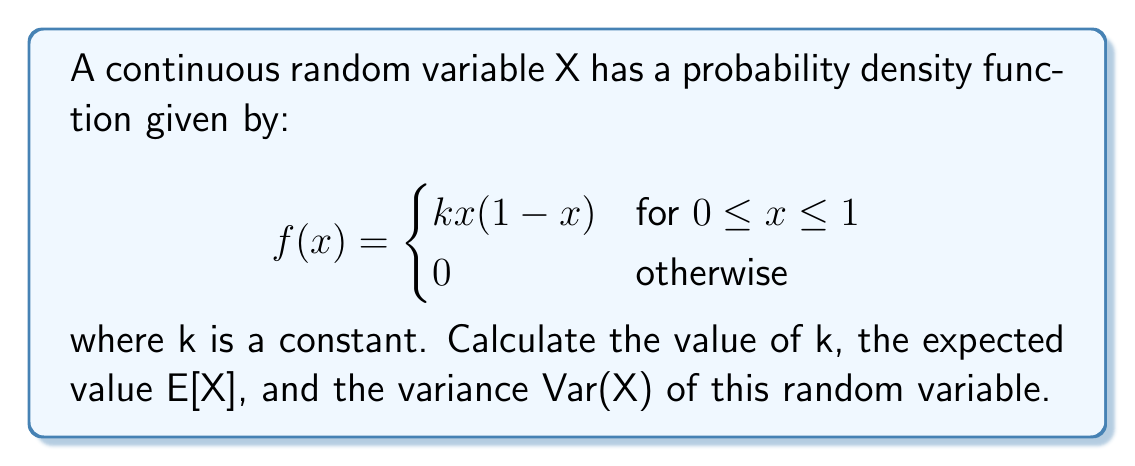What is the answer to this math problem? 1. First, we need to find the value of k. Since this is a probability density function, the total area under the curve must equal 1:

   $$\int_{0}^{1} kx(1-x) dx = 1$$

   Solving this integral:
   $$k \int_{0}^{1} (x - x^2) dx = 1$$
   $$k [\frac{x^2}{2} - \frac{x^3}{3}]_{0}^{1} = 1$$
   $$k (\frac{1}{2} - \frac{1}{3}) = 1$$
   $$k = 6$$

2. Now we can calculate the expected value E[X]:

   $$E[X] = \int_{0}^{1} x \cdot 6x(1-x) dx$$
   $$= 6 \int_{0}^{1} (x^2 - x^3) dx$$
   $$= 6 [\frac{x^3}{3} - \frac{x^4}{4}]_{0}^{1}$$
   $$= 6 (\frac{1}{3} - \frac{1}{4}) = 6 \cdot \frac{1}{12} = \frac{1}{2}$$

3. To find the variance, we first need to calculate E[X^2]:

   $$E[X^2] = \int_{0}^{1} x^2 \cdot 6x(1-x) dx$$
   $$= 6 \int_{0}^{1} (x^3 - x^4) dx$$
   $$= 6 [\frac{x^4}{4} - \frac{x^5}{5}]_{0}^{1}$$
   $$= 6 (\frac{1}{4} - \frac{1}{5}) = 6 \cdot \frac{1}{20} = \frac{3}{10}$$

4. Now we can calculate the variance:

   $$Var(X) = E[X^2] - (E[X])^2$$
   $$= \frac{3}{10} - (\frac{1}{2})^2$$
   $$= \frac{3}{10} - \frac{1}{4} = \frac{1}{20}$$
Answer: $k = 6$, $E[X] = \frac{1}{2}$, $Var(X) = \frac{1}{20}$ 